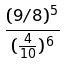Convert formula to latex. <formula><loc_0><loc_0><loc_500><loc_500>\frac { ( 9 / 8 ) ^ { 5 } } { ( \frac { 4 } { 1 0 } ) ^ { 6 } }</formula> 